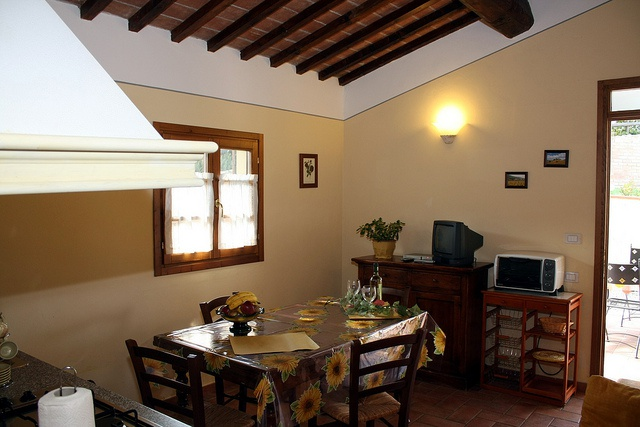Describe the objects in this image and their specific colors. I can see dining table in lightgray, maroon, black, and white tones, chair in lightgray, black, maroon, and gray tones, chair in lightgray, black, maroon, and gray tones, microwave in lightgray, black, gray, and darkgray tones, and chair in lightgray, maroon, and olive tones in this image. 